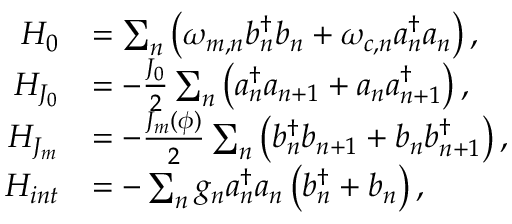Convert formula to latex. <formula><loc_0><loc_0><loc_500><loc_500>\begin{array} { r l } { H _ { 0 } } & { = \sum _ { n } \left ( \omega _ { m , n } b _ { n } ^ { \dagger } b _ { n } + \omega _ { c , n } a _ { n } ^ { \dagger } a _ { n } \right ) , } \\ { H _ { J _ { 0 } } } & { = - \frac { J _ { 0 } } { 2 } \sum _ { n } \left ( a _ { n } ^ { \dagger } a _ { n + 1 } + a _ { n } a _ { n + 1 } ^ { \dagger } \right ) , } \\ { H _ { J _ { m } } } & { = - \frac { J _ { m } ( \phi ) } { 2 } \sum _ { n } \left ( b _ { n } ^ { \dagger } b _ { n + 1 } + b _ { n } b _ { n + 1 } ^ { \dagger } \right ) , } \\ { H _ { i n t } } & { = - \sum _ { n } g _ { n } a _ { n } ^ { \dagger } a _ { n } \left ( b _ { n } ^ { \dagger } + b _ { n } \right ) , } \end{array}</formula> 